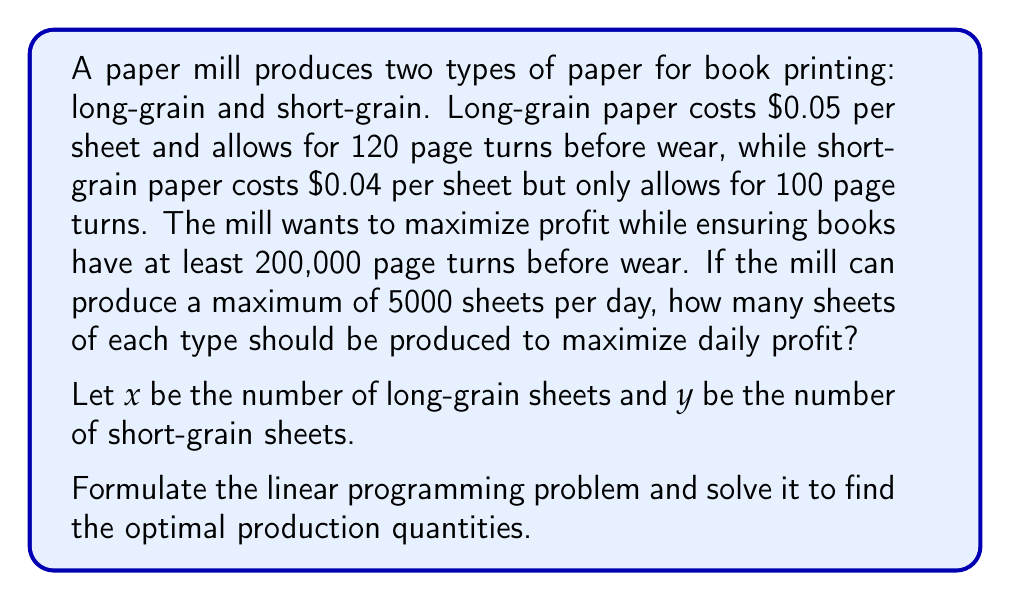Help me with this question. To solve this optimization problem, we need to set up a linear programming model and then solve it.

1. Define the objective function:
   Profit = Revenue - Cost
   $P = 0.05x + 0.04y$ (maximize)

2. Constraints:
   a. Page turn requirement: $120x + 100y \geq 200000$
   b. Production capacity: $x + y \leq 5000$
   c. Non-negativity: $x \geq 0, y \geq 0$

3. The linear programming problem:
   Maximize: $P = 0.05x + 0.04y$
   Subject to:
   $120x + 100y \geq 200000$
   $x + y \leq 5000$
   $x \geq 0, y \geq 0$

4. To solve this, we can use the graphical method or the simplex algorithm. Let's use the graphical method:

   a. Plot the constraints:
      [asy]
      import graph;
      size(200,200);
      xaxis("x (long-grain)", 0, 5000, Arrow);
      yaxis("y (short-grain)", 0, 5000, Arrow);
      draw((0,2000)--(1666.67,0), blue);
      draw((0,5000)--(5000,0), red);
      label("120x + 100y = 200000", (800,1000), blue);
      label("x + y = 5000", (2000,3000), red);
      fill((0,2000)--(1666.67,0)--(5000,0)--(0,5000)--cycle, paleblue+opacity(0.2));
      [/asy]

   b. The feasible region is the shaded area.

   c. The optimal solution will be at one of the corner points. We need to evaluate the objective function at these points:
      - (0, 2000): $P = 0.04 * 2000 = 80$
      - (1666.67, 0): $P = 0.05 * 1666.67 = 83.33$
      - (833.33, 4166.67): $P = 0.05 * 833.33 + 0.04 * 4166.67 = 208.33$

5. The optimal solution is at the point (833.33, 4166.67), which gives the maximum profit of $208.33.
Answer: The optimal production quantities are approximately 833 sheets of long-grain paper and 4167 sheets of short-grain paper, resulting in a maximum daily profit of $208.33. 